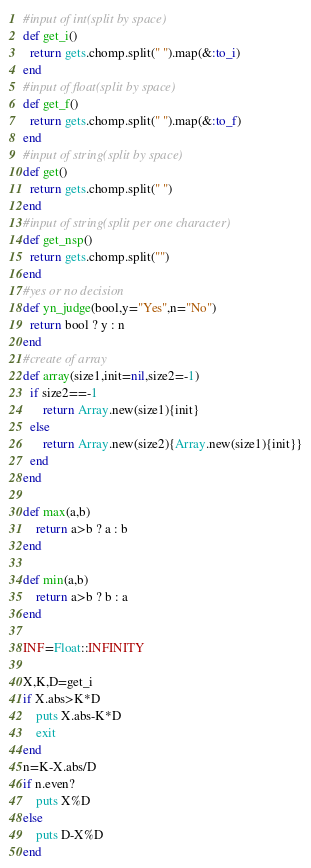Convert code to text. <code><loc_0><loc_0><loc_500><loc_500><_Ruby_>#input of int(split by space)
def get_i()
  return gets.chomp.split(" ").map(&:to_i)
end
#input of float(split by space)
def get_f()
  return gets.chomp.split(" ").map(&:to_f)
end
#input of string(split by space)
def get()
  return gets.chomp.split(" ")
end
#input of string(split per one character)
def get_nsp()
  return gets.chomp.split("")
end
#yes or no decision
def yn_judge(bool,y="Yes",n="No")
  return bool ? y : n 
end
#create of array
def array(size1,init=nil,size2=-1)
  if size2==-1
      return Array.new(size1){init}
  else
      return Array.new(size2){Array.new(size1){init}}
  end
end

def max(a,b)
    return a>b ? a : b
end

def min(a,b)
    return a>b ? b : a
end

INF=Float::INFINITY

X,K,D=get_i
if X.abs>K*D
    puts X.abs-K*D
    exit
end
n=K-X.abs/D
if n.even?
    puts X%D
else
    puts D-X%D
end</code> 